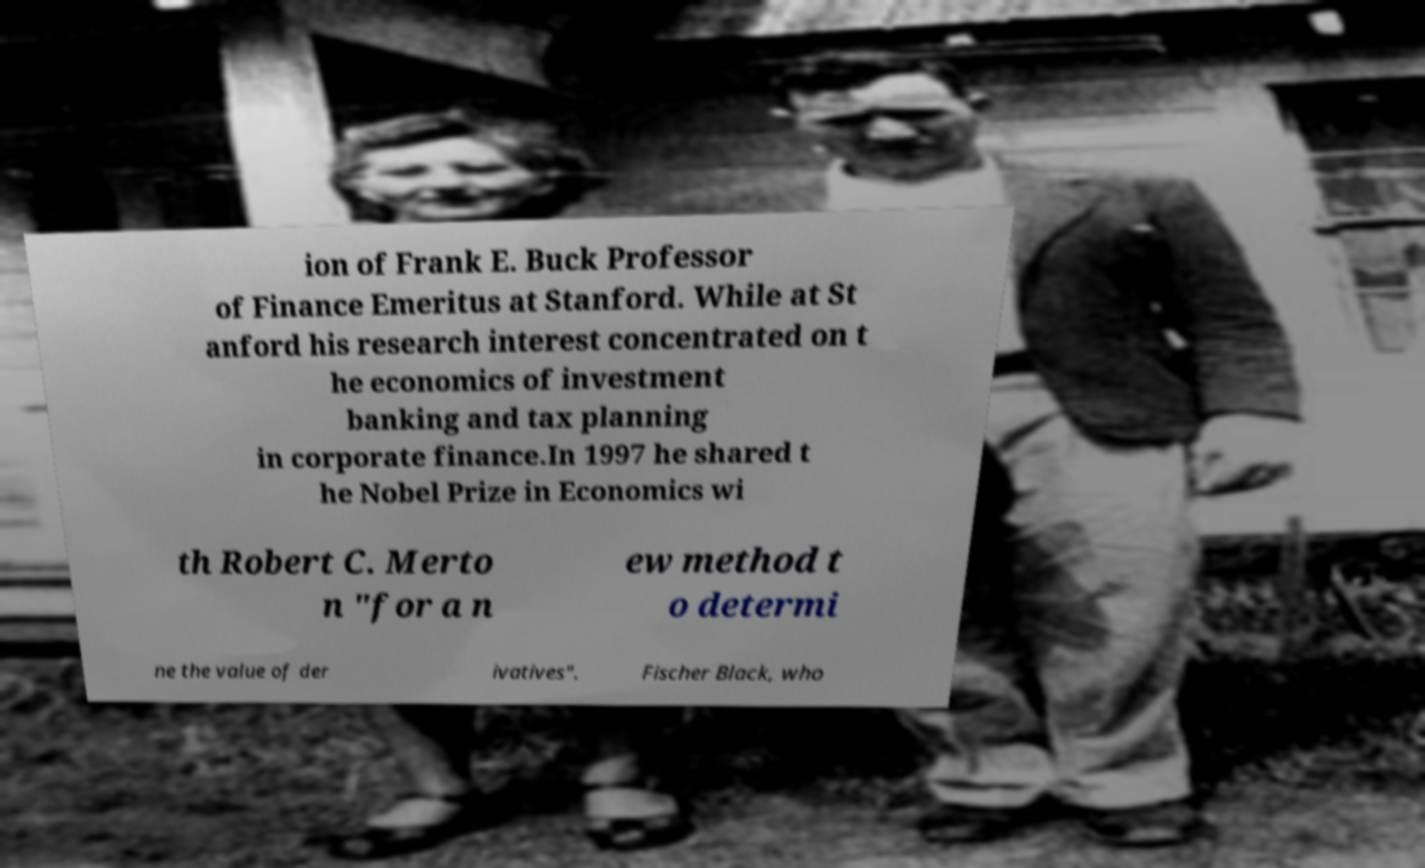Please read and relay the text visible in this image. What does it say? ion of Frank E. Buck Professor of Finance Emeritus at Stanford. While at St anford his research interest concentrated on t he economics of investment banking and tax planning in corporate finance.In 1997 he shared t he Nobel Prize in Economics wi th Robert C. Merto n "for a n ew method t o determi ne the value of der ivatives". Fischer Black, who 